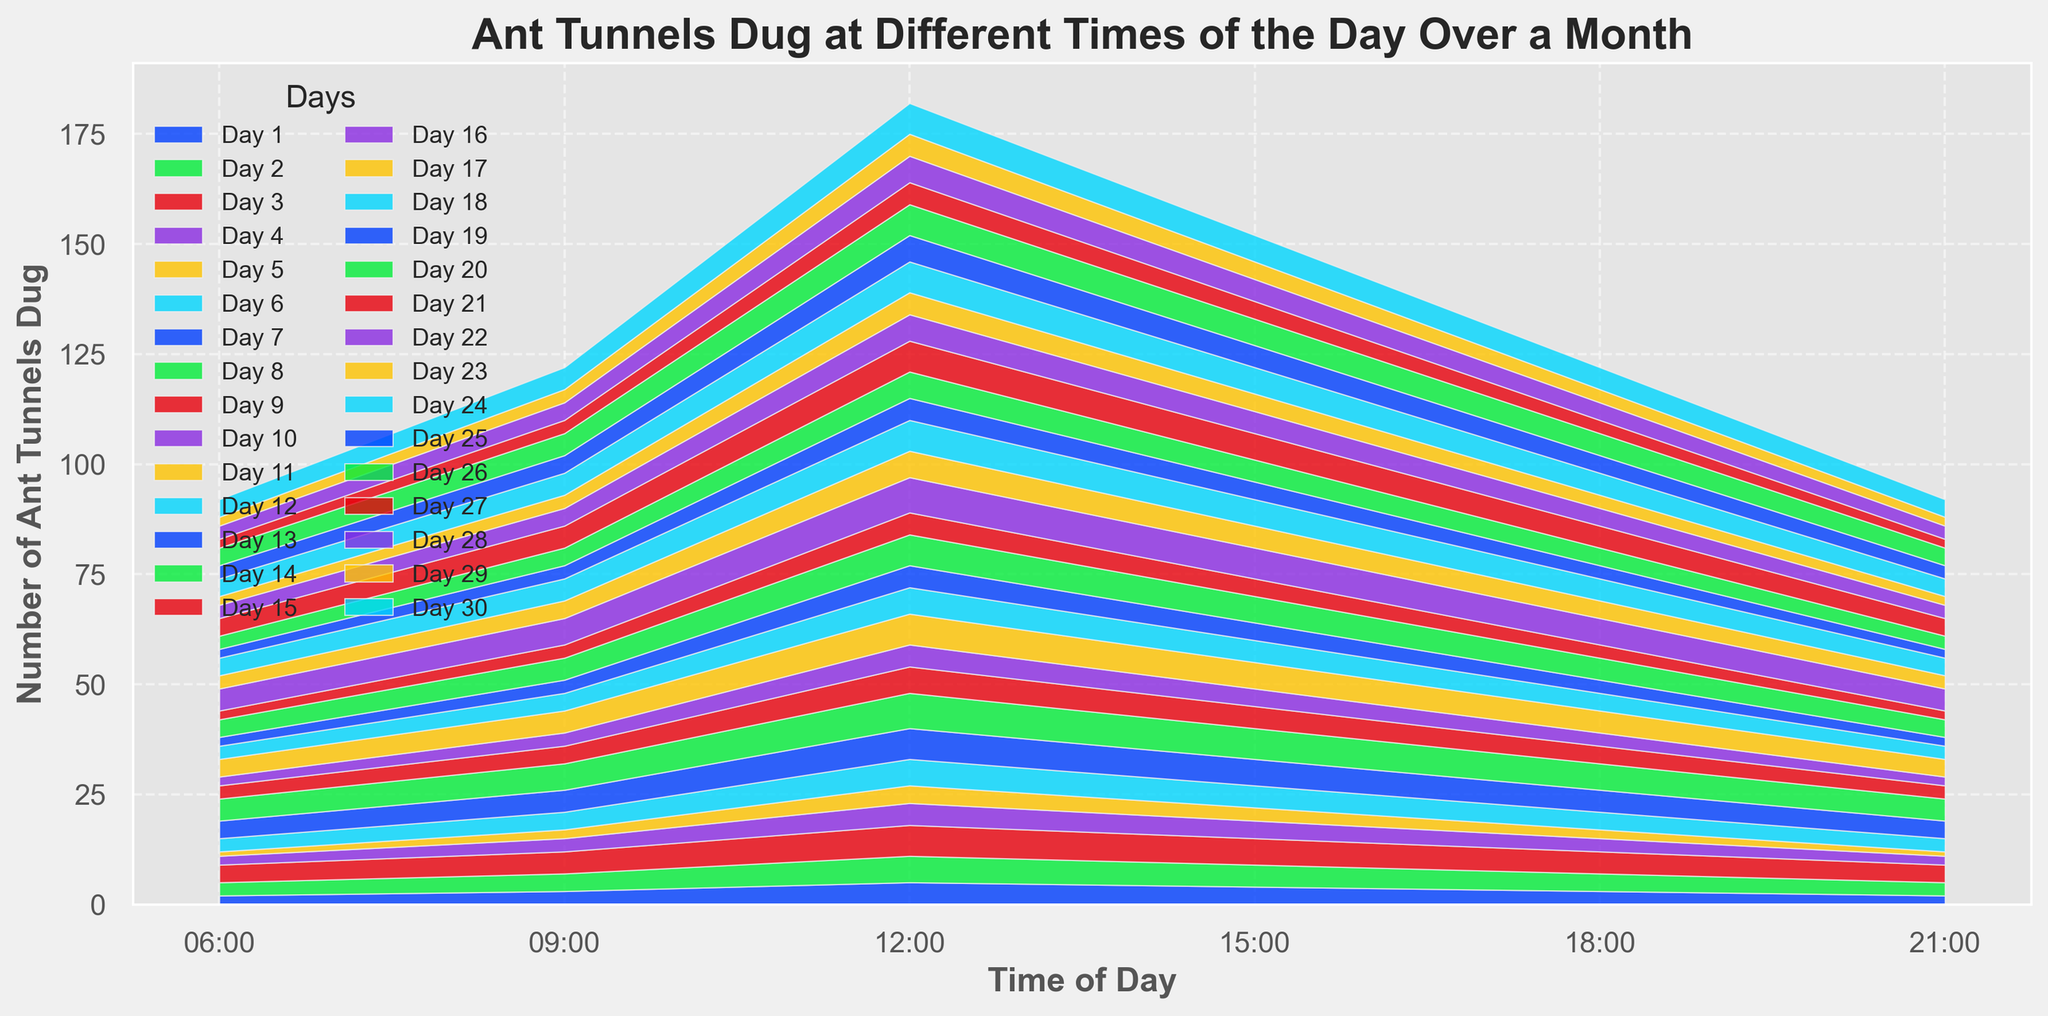What time of day do the ants dig the most tunnels on average? To find the time of day when ants dig the most tunnels on average, calculate the average number of tunnels dug at each time across all days. Sum the values for each time category and divide by the number of days (30). Compare these averages to identify the time with the highest value.
Answer: 12:00 Which time of day shows the least variation in the number of tunnels dug throughout the month? To determine the time of day with the least variation, observe the different times and note the range of tunnel numbers for each time slot. The time with the smallest difference between the highest and lowest values indicates the least variation.
Answer: 21:00 Do ants dig more tunnels during the morning (6:00 and 9:00) or evening (18:00 and 21:00) on average? First, sum the number of tunnels dug at 6:00 and 9:00 for all days, and then divide by 60 (the total entries). Do the same for tunnels dug at 18:00 and 21:00. Compare the two averages to determine which period has more tunnels dug.
Answer: Morning Between 12:00 and 15:00, which time has more variation in the number of tunnels dug? Calculate the range (highest value - lowest value) of tunnels dug at 12:00 and 15:00. The time with the higher range has more variation.
Answer: 15:00 On which day was the maximum number of tunnels dug at 6:00? Review the values under the 6:00 time slot across all days and identify the day with the highest number.
Answer: Day 8 Is there a noticeable pattern in the number of tunnels dug throughout the day? By visually inspecting the area chart, note if there's a pattern where the number of tunnels dug increases or decreases systematically at certain times of the day.
Answer: Yes, more tunnels are dug around midday (12:00) and fewer during early morning (6:00) and late evening (21:00) Compare the number of tunnels dug at 9:00 and 18:00 on Day 15. Which time had more tunnels? Refer to the chart for Day 15's data points at 9:00 and 18:00 and compare their values to see which is higher.
Answer: 9:00 Which day had the highest number of tunnels dug overall? Sum the number of tunnels dug at all times for each day. The day with the highest sum is the one with the most tunnels dug overall.
Answer: Day 15 